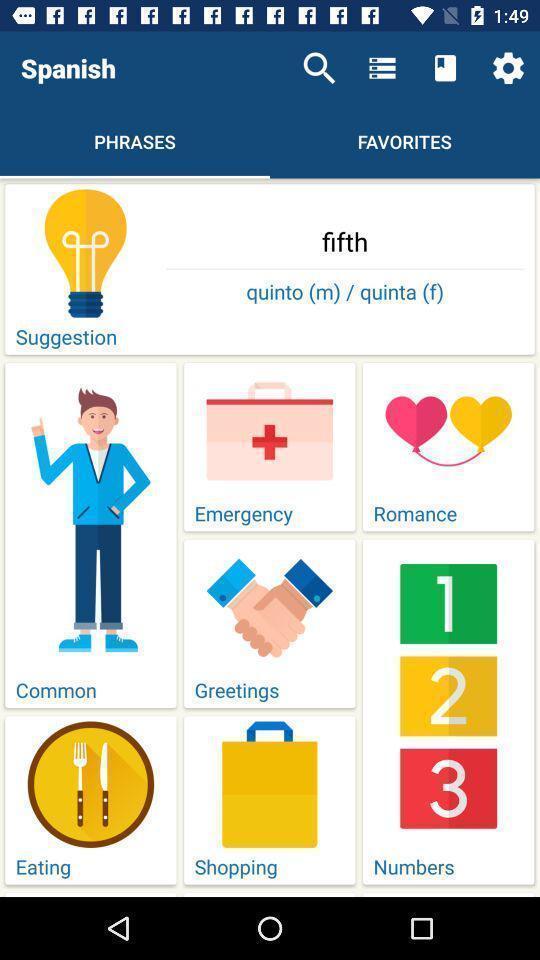Give me a summary of this screen capture. Screen showing list of various phrases of a learning app. 